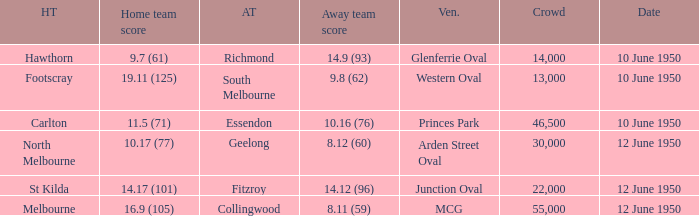What was the crowd when Melbourne was the home team? 55000.0. 